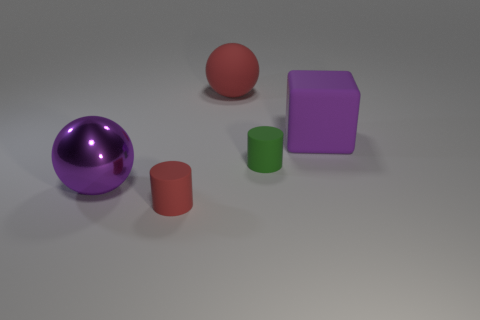How many other objects are there of the same color as the rubber block?
Keep it short and to the point. 1. Are there any other things that are the same size as the purple rubber block?
Keep it short and to the point. Yes. Are there any purple things in front of the purple metal thing?
Ensure brevity in your answer.  No. The large metal thing that is behind the small thing in front of the large sphere on the left side of the small red rubber object is what color?
Your answer should be very brief. Purple. What shape is the purple rubber object that is the same size as the purple metal thing?
Offer a terse response. Cube. Is the number of big red matte balls greater than the number of big spheres?
Provide a short and direct response. No. There is a large rubber object that is behind the large rubber cube; are there any large rubber objects that are on the left side of it?
Offer a very short reply. No. The other large metal object that is the same shape as the big red object is what color?
Provide a succinct answer. Purple. Is there any other thing that is the same shape as the small red matte thing?
Give a very brief answer. Yes. The large thing that is made of the same material as the cube is what color?
Provide a succinct answer. Red. 